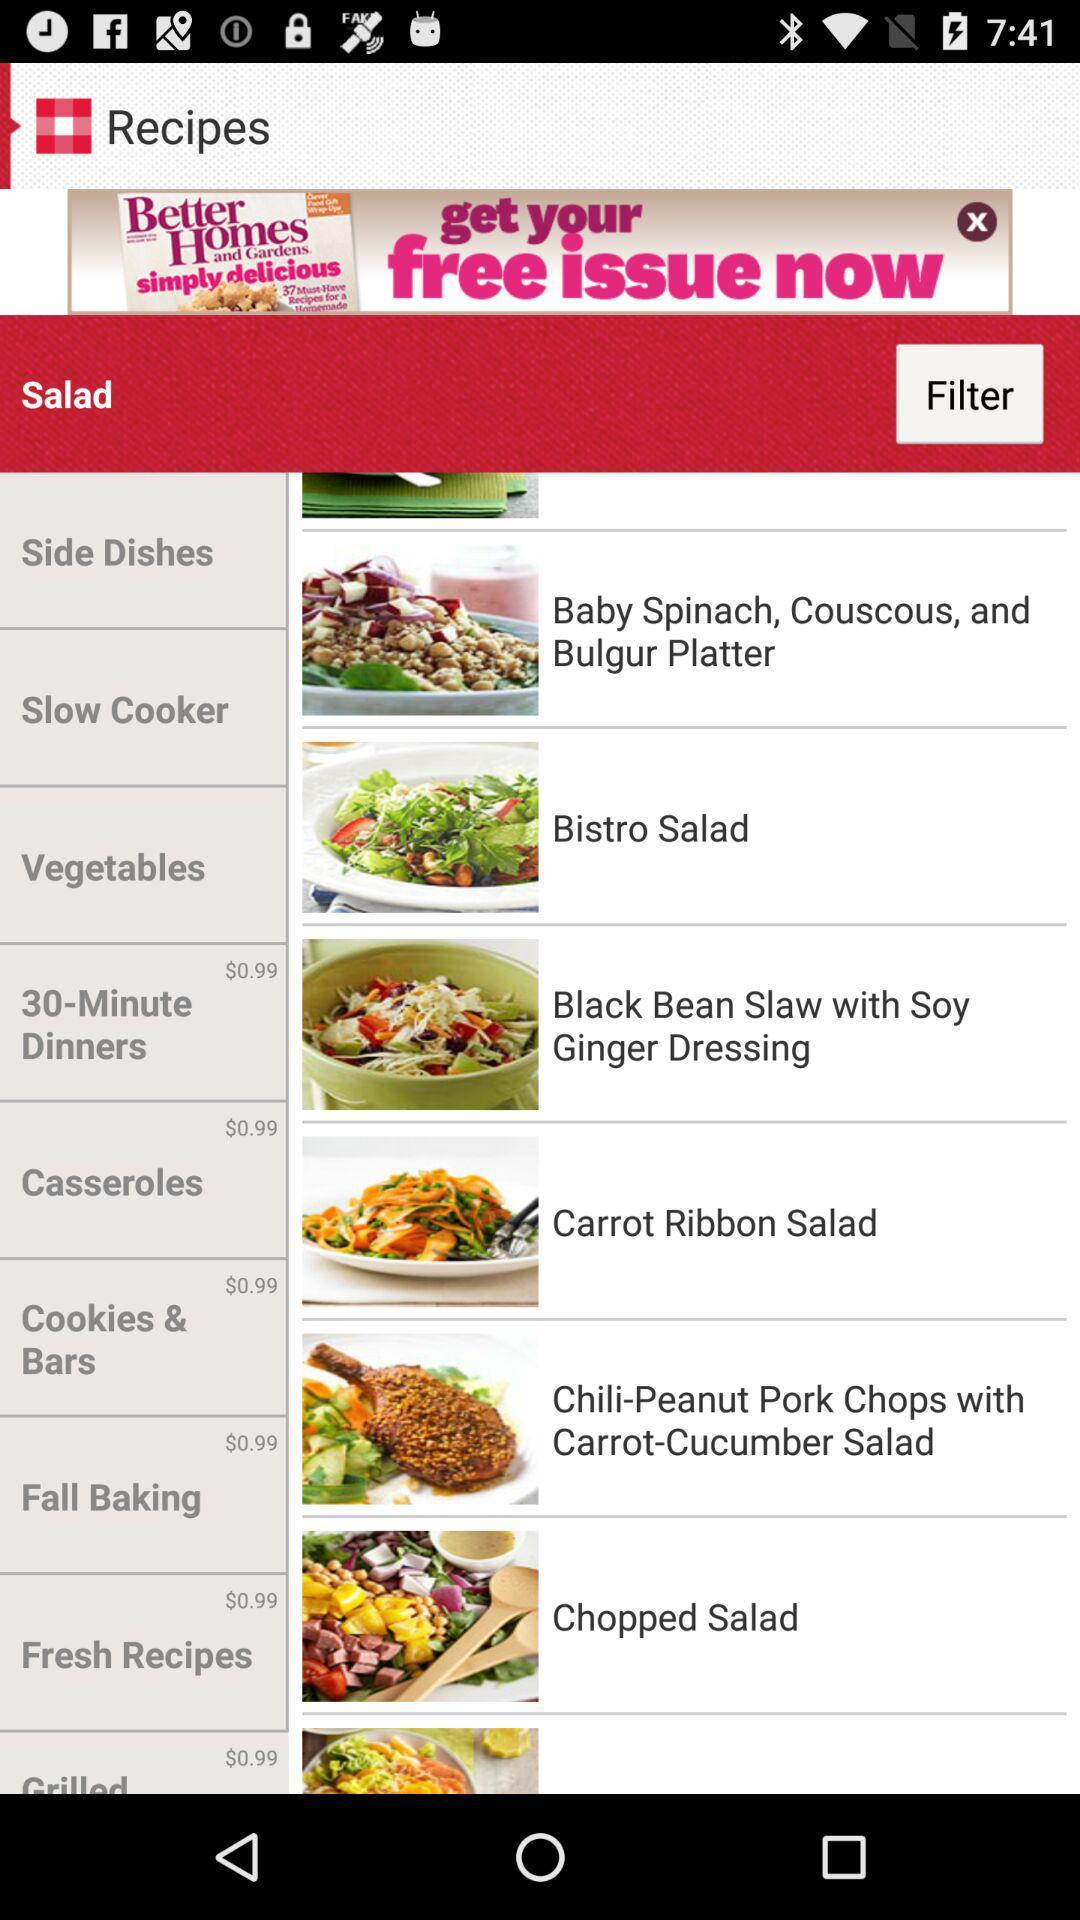What is the price of "Fresh Recipes"? The price is $0.99. 